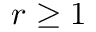<formula> <loc_0><loc_0><loc_500><loc_500>r \geq 1</formula> 